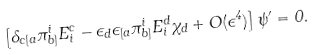Convert formula to latex. <formula><loc_0><loc_0><loc_500><loc_500>\left [ \delta _ { c [ a } \pi ^ { i } _ { b ] } E ^ { c } _ { i } - \epsilon _ { d } \epsilon _ { [ a } \pi ^ { i } _ { b ] } E ^ { d } _ { i } \chi _ { d } + O ( \epsilon ^ { 4 } ) \right ] \psi ^ { \prime } = 0 .</formula> 